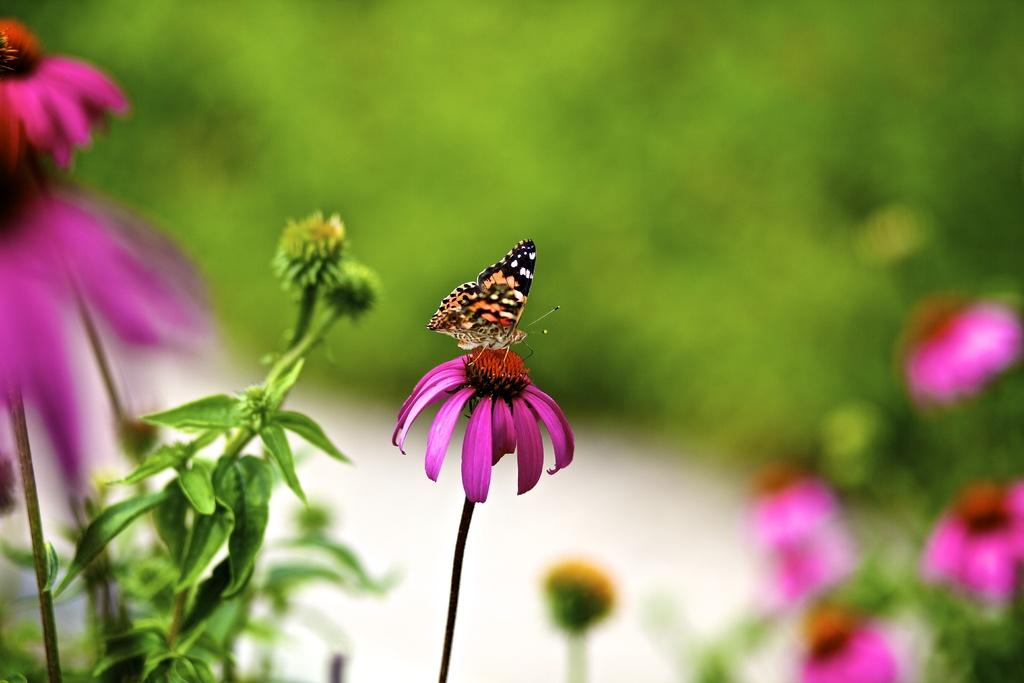What is on the flower in the image? There is a butterfly on a flower in the image. What else can be seen in the image besides the butterfly? There are flowers and plants in the image. How is the background of the image depicted? The background of the image is blurred. What statement does the butterfly make in the image? Butterflies do not make statements; they are insects that cannot speak or communicate through language. 